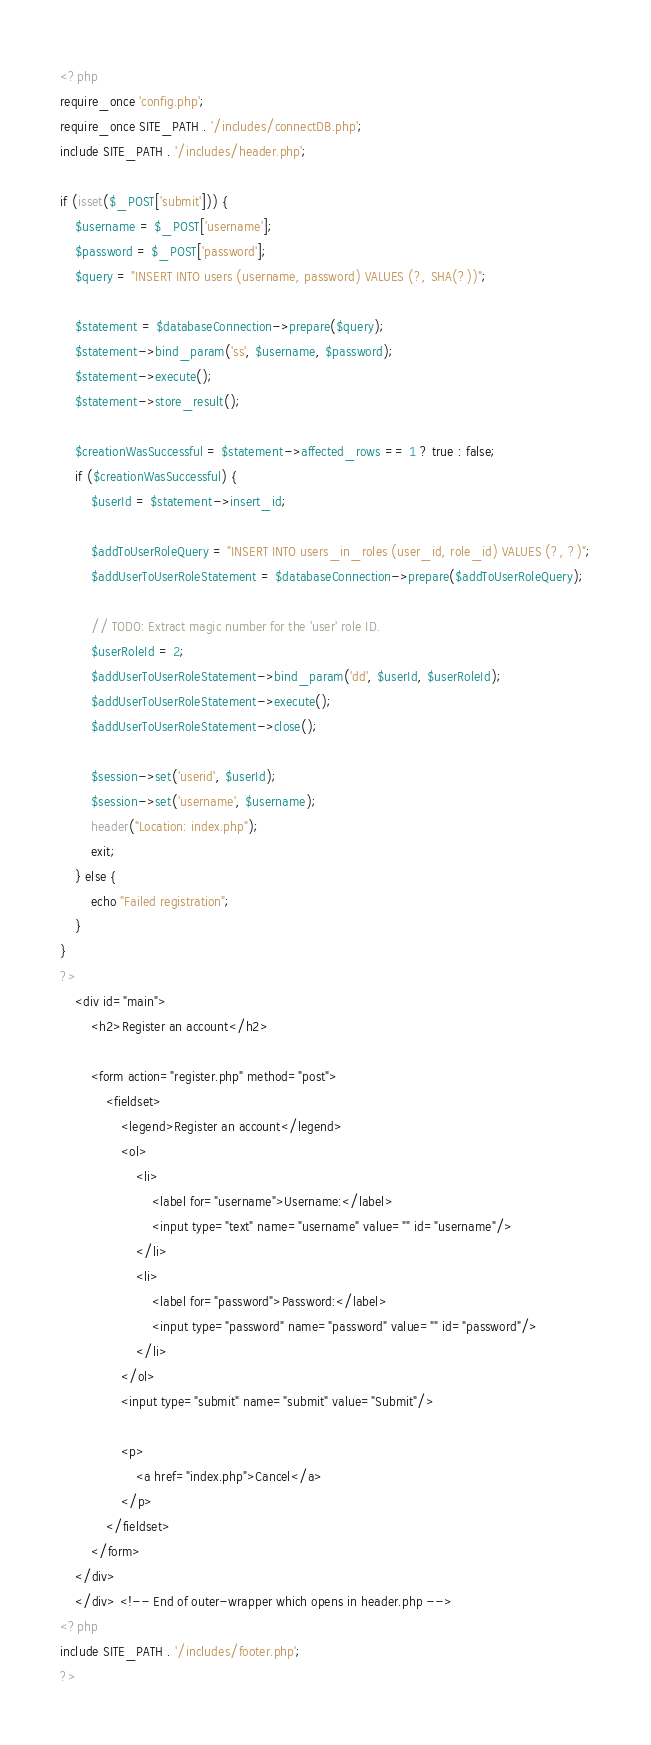<code> <loc_0><loc_0><loc_500><loc_500><_PHP_><?php
require_once 'config.php';
require_once SITE_PATH . '/includes/connectDB.php';
include SITE_PATH . '/includes/header.php';

if (isset($_POST['submit'])) {
    $username = $_POST['username'];
    $password = $_POST['password'];
    $query = "INSERT INTO users (username, password) VALUES (?, SHA(?))";

    $statement = $databaseConnection->prepare($query);
    $statement->bind_param('ss', $username, $password);
    $statement->execute();
    $statement->store_result();

    $creationWasSuccessful = $statement->affected_rows == 1 ? true : false;
    if ($creationWasSuccessful) {
        $userId = $statement->insert_id;

        $addToUserRoleQuery = "INSERT INTO users_in_roles (user_id, role_id) VALUES (?, ?)";
        $addUserToUserRoleStatement = $databaseConnection->prepare($addToUserRoleQuery);

        // TODO: Extract magic number for the 'user' role ID.
        $userRoleId = 2;
        $addUserToUserRoleStatement->bind_param('dd', $userId, $userRoleId);
        $addUserToUserRoleStatement->execute();
        $addUserToUserRoleStatement->close();

        $session->set('userid', $userId);
        $session->set('username', $username);
        header("Location: index.php");
        exit;
    } else {
        echo "Failed registration";
    }
}
?>
    <div id="main">
        <h2>Register an account</h2>

        <form action="register.php" method="post">
            <fieldset>
                <legend>Register an account</legend>
                <ol>
                    <li>
                        <label for="username">Username:</label>
                        <input type="text" name="username" value="" id="username"/>
                    </li>
                    <li>
                        <label for="password">Password:</label>
                        <input type="password" name="password" value="" id="password"/>
                    </li>
                </ol>
                <input type="submit" name="submit" value="Submit"/>

                <p>
                    <a href="index.php">Cancel</a>
                </p>
            </fieldset>
        </form>
    </div>
    </div> <!-- End of outer-wrapper which opens in header.php -->
<?php
include SITE_PATH . '/includes/footer.php';
?>
</code> 